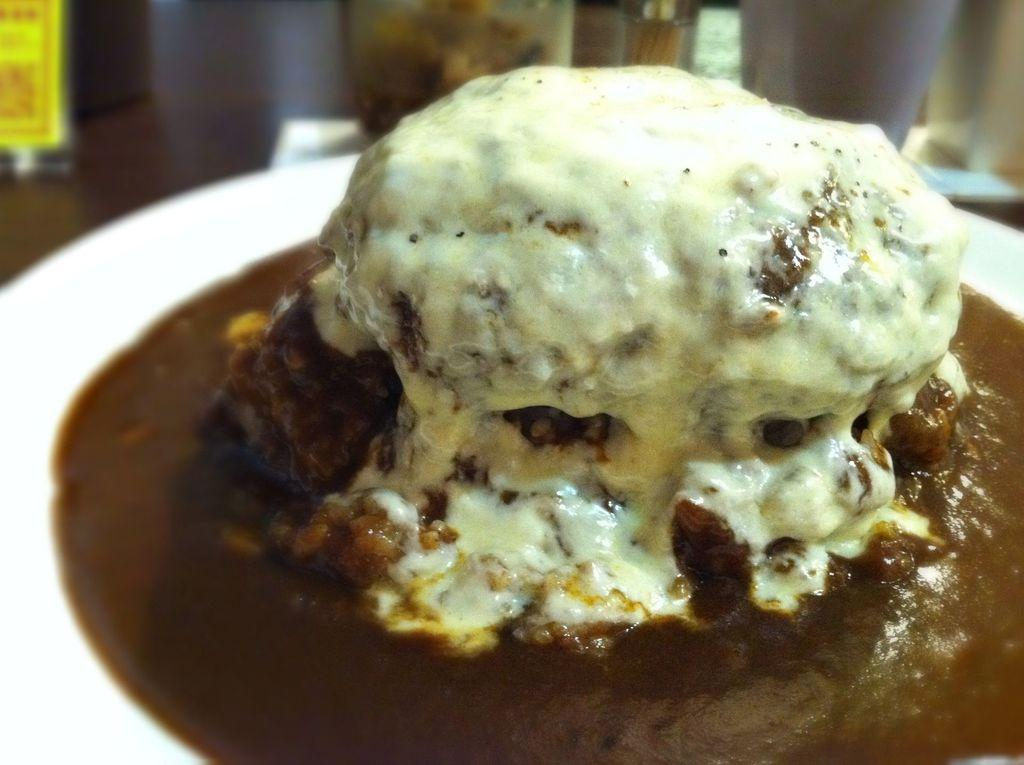What type of food is featured in the image? There is a dessert in the image. How is the dessert presented? The dessert is on a serving plate. What type of flag is visible in the image? There is no flag present in the image. What type of trees can be seen in the image? There are no trees visible in the image. 